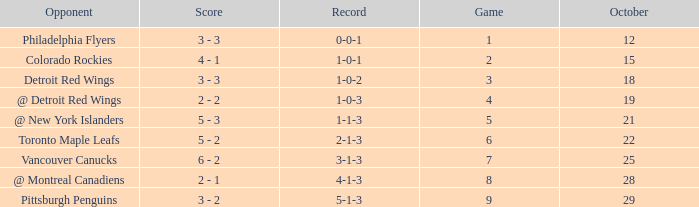Name the score for game more than 6 and before october 28 6 - 2. 